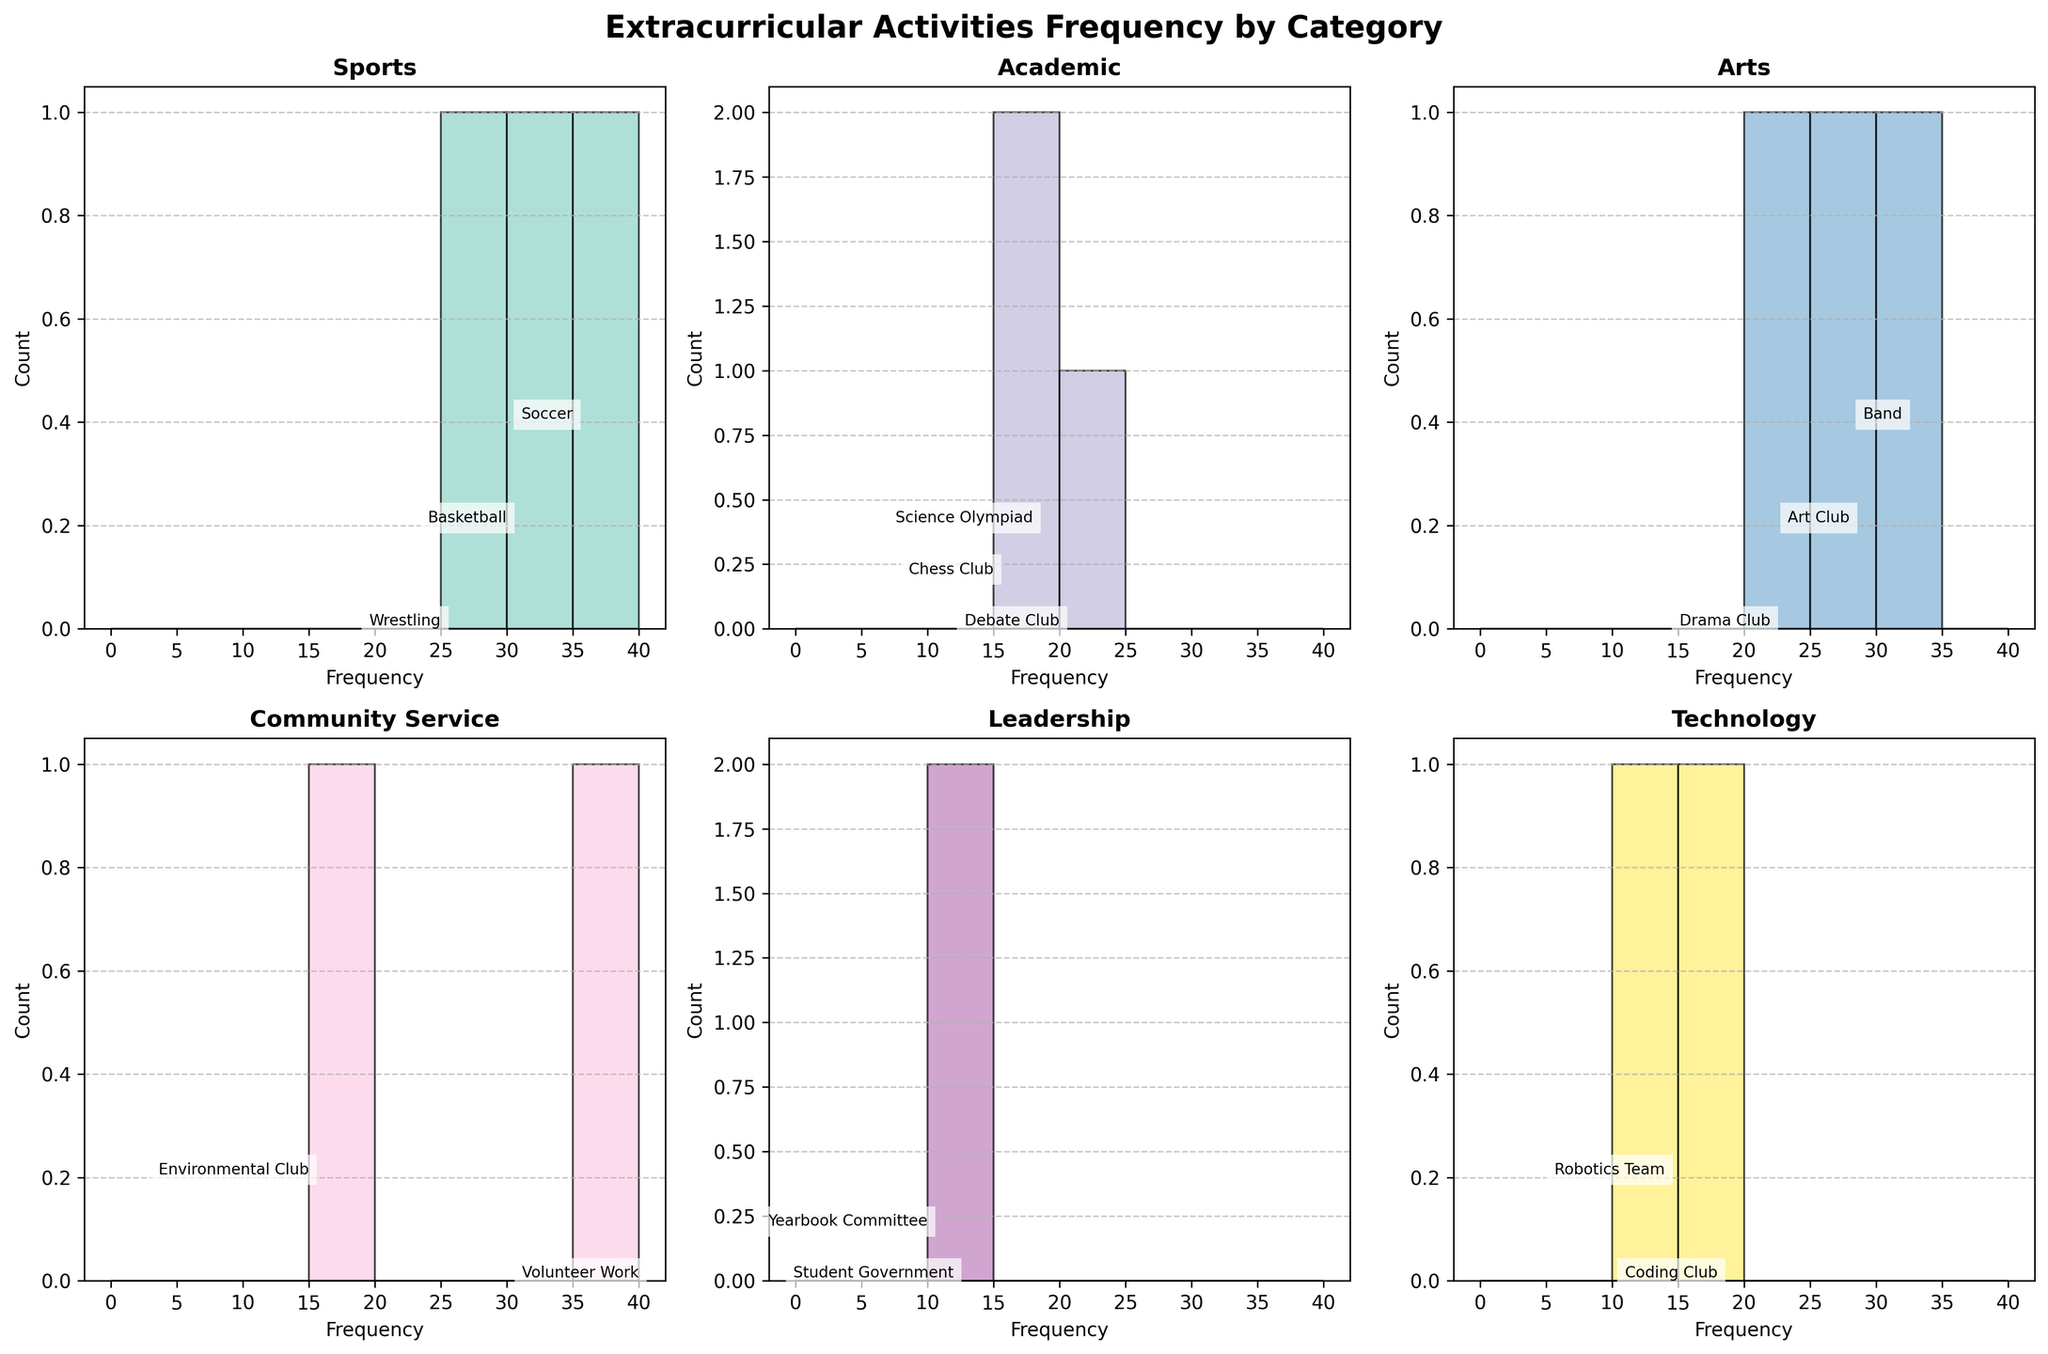what is the title of the figure? The title of the figure is provided at the top, which reads "Extracurricular Activities Frequency by Category". This title summarizes what the entire figure is about.
Answer: Extracurricular Activities Frequency by Category how many categories are represented in the figure? The figure displays subplots for each unique category apart from the main figure title, resulting in the observation of five unique categories (Sports, Academic, Arts, Community Service, Leadership, Technology).
Answer: five which category has the most frequent activity? By looking at the histograms, we can compare the highest frequency in each category. The Community Service category has the most frequent activity, with Volunteer Work showing a frequency of 40.
Answer: Community Service which activity has the highest frequency in the Sports category? In the Sports category histogram, the tallest bar corresponds to Soccer, which shows the highest frequency of 35.
Answer: Soccer how does the frequency of Volunteer Work compare to Band? Comparing the histograms of Community Service and Arts categories, Volunteer Work has a higher frequency (40) compared to Band (32).
Answer: Volunteer Work has a higher frequency what is the total frequency for the Arts category? Summing up the frequencies of all activities in the Arts category: Drama Club (22), Art Club (28), and Band (32), gives 22 + 28 + 32 = 82.
Answer: 82 which category has the fewest activities? By counting the number of data points in each subplot, the Leadership category has the fewest activities with only two activities displayed (Student Government and Yearbook Committee).
Answer: Leadership what is the average frequency of activities in the Academic category? The Academic category includes Debate Club (20), Chess Club (15), and Science Olympiad (18). Calculating the average: (20 + 15 + 18) / 3 = 53 / 3 ≈ 17.67.
Answer: 17.67 does Robotics Team have a higher frequency than Chess Club? Comparing their frequencies shown in their respective histograms, Chess Club (15) has a higher frequency than Robotics Team (14).
Answer: No what is the range of frequencies for activities in Technology? The Technology category includes Coding Club (18) and Robotics Team (14). The range is calculated as the difference between the highest and lowest values: 18 - 14 = 4.
Answer: 4 